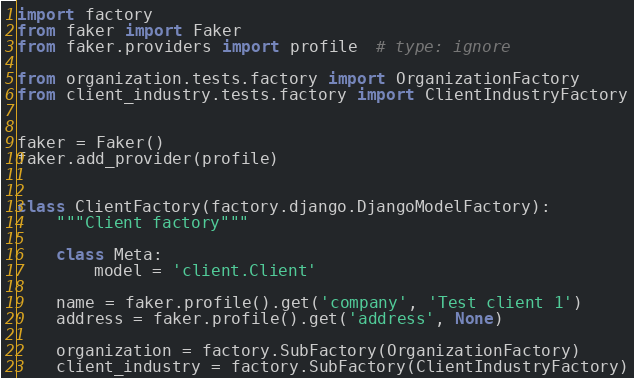<code> <loc_0><loc_0><loc_500><loc_500><_Python_>import factory
from faker import Faker
from faker.providers import profile  # type: ignore

from organization.tests.factory import OrganizationFactory
from client_industry.tests.factory import ClientIndustryFactory


faker = Faker()
faker.add_provider(profile)


class ClientFactory(factory.django.DjangoModelFactory):
    """Client factory"""

    class Meta:
        model = 'client.Client'

    name = faker.profile().get('company', 'Test client 1')
    address = faker.profile().get('address', None)

    organization = factory.SubFactory(OrganizationFactory)
    client_industry = factory.SubFactory(ClientIndustryFactory)
</code> 